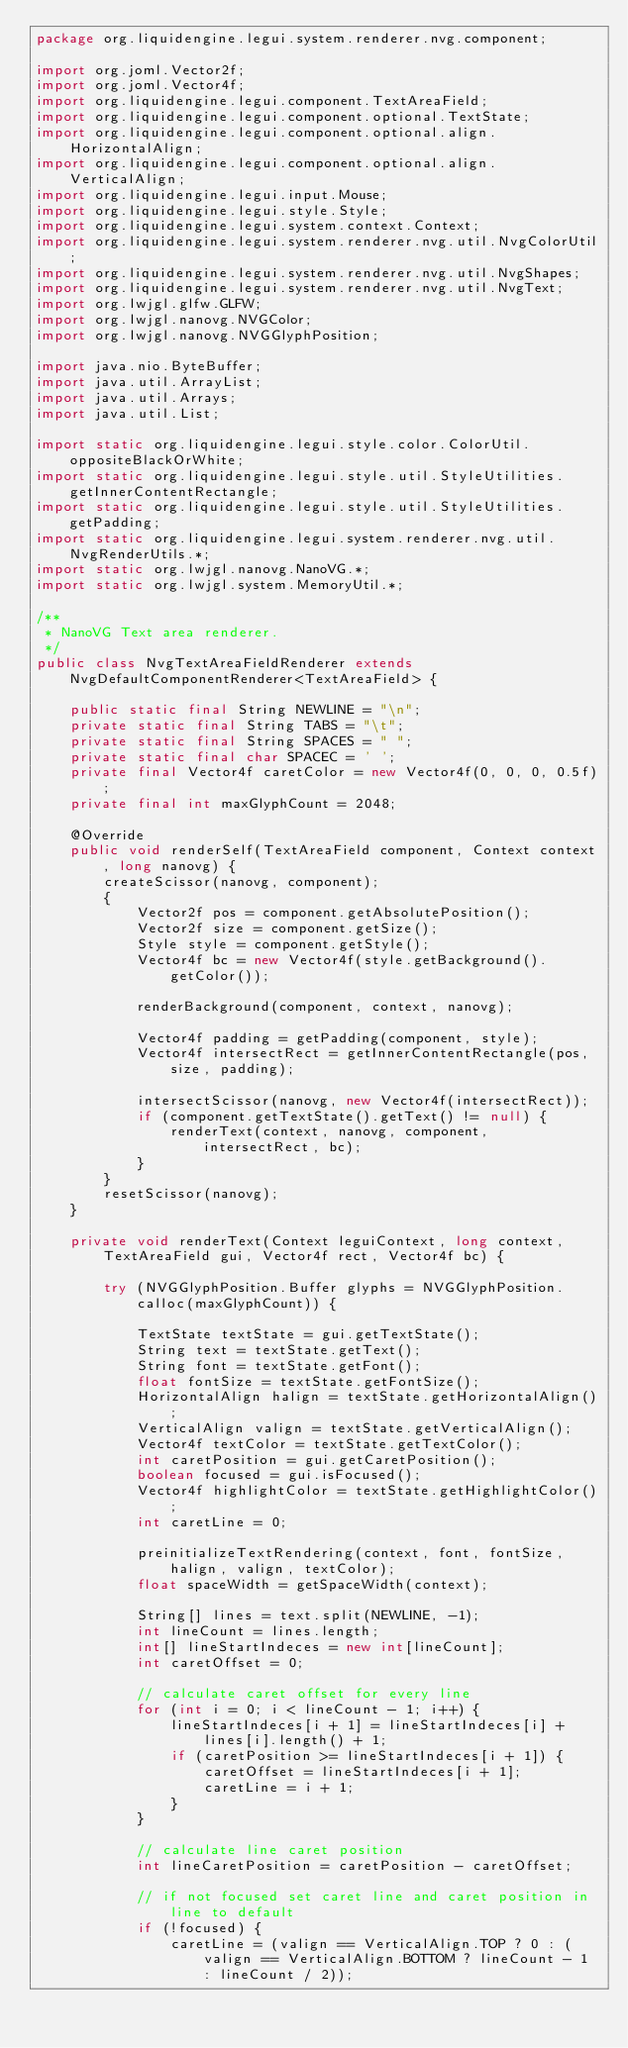Convert code to text. <code><loc_0><loc_0><loc_500><loc_500><_Java_>package org.liquidengine.legui.system.renderer.nvg.component;

import org.joml.Vector2f;
import org.joml.Vector4f;
import org.liquidengine.legui.component.TextAreaField;
import org.liquidengine.legui.component.optional.TextState;
import org.liquidengine.legui.component.optional.align.HorizontalAlign;
import org.liquidengine.legui.component.optional.align.VerticalAlign;
import org.liquidengine.legui.input.Mouse;
import org.liquidengine.legui.style.Style;
import org.liquidengine.legui.system.context.Context;
import org.liquidengine.legui.system.renderer.nvg.util.NvgColorUtil;
import org.liquidengine.legui.system.renderer.nvg.util.NvgShapes;
import org.liquidengine.legui.system.renderer.nvg.util.NvgText;
import org.lwjgl.glfw.GLFW;
import org.lwjgl.nanovg.NVGColor;
import org.lwjgl.nanovg.NVGGlyphPosition;

import java.nio.ByteBuffer;
import java.util.ArrayList;
import java.util.Arrays;
import java.util.List;

import static org.liquidengine.legui.style.color.ColorUtil.oppositeBlackOrWhite;
import static org.liquidengine.legui.style.util.StyleUtilities.getInnerContentRectangle;
import static org.liquidengine.legui.style.util.StyleUtilities.getPadding;
import static org.liquidengine.legui.system.renderer.nvg.util.NvgRenderUtils.*;
import static org.lwjgl.nanovg.NanoVG.*;
import static org.lwjgl.system.MemoryUtil.*;

/**
 * NanoVG Text area renderer.
 */
public class NvgTextAreaFieldRenderer extends NvgDefaultComponentRenderer<TextAreaField> {

    public static final String NEWLINE = "\n";
    private static final String TABS = "\t";
    private static final String SPACES = " ";
    private static final char SPACEC = ' ';
    private final Vector4f caretColor = new Vector4f(0, 0, 0, 0.5f);
    private final int maxGlyphCount = 2048;

    @Override
    public void renderSelf(TextAreaField component, Context context, long nanovg) {
        createScissor(nanovg, component);
        {
            Vector2f pos = component.getAbsolutePosition();
            Vector2f size = component.getSize();
            Style style = component.getStyle();
            Vector4f bc = new Vector4f(style.getBackground().getColor());

            renderBackground(component, context, nanovg);

            Vector4f padding = getPadding(component, style);
            Vector4f intersectRect = getInnerContentRectangle(pos, size, padding);

            intersectScissor(nanovg, new Vector4f(intersectRect));
            if (component.getTextState().getText() != null) {
                renderText(context, nanovg, component, intersectRect, bc);
            }
        }
        resetScissor(nanovg);
    }

    private void renderText(Context leguiContext, long context, TextAreaField gui, Vector4f rect, Vector4f bc) {

        try (NVGGlyphPosition.Buffer glyphs = NVGGlyphPosition.calloc(maxGlyphCount)) {

            TextState textState = gui.getTextState();
            String text = textState.getText();
            String font = textState.getFont();
            float fontSize = textState.getFontSize();
            HorizontalAlign halign = textState.getHorizontalAlign();
            VerticalAlign valign = textState.getVerticalAlign();
            Vector4f textColor = textState.getTextColor();
            int caretPosition = gui.getCaretPosition();
            boolean focused = gui.isFocused();
            Vector4f highlightColor = textState.getHighlightColor();
            int caretLine = 0;

            preinitializeTextRendering(context, font, fontSize, halign, valign, textColor);
            float spaceWidth = getSpaceWidth(context);

            String[] lines = text.split(NEWLINE, -1);
            int lineCount = lines.length;
            int[] lineStartIndeces = new int[lineCount];
            int caretOffset = 0;

            // calculate caret offset for every line
            for (int i = 0; i < lineCount - 1; i++) {
                lineStartIndeces[i + 1] = lineStartIndeces[i] + lines[i].length() + 1;
                if (caretPosition >= lineStartIndeces[i + 1]) {
                    caretOffset = lineStartIndeces[i + 1];
                    caretLine = i + 1;
                }
            }

            // calculate line caret position
            int lineCaretPosition = caretPosition - caretOffset;

            // if not focused set caret line and caret position in line to default
            if (!focused) {
                caretLine = (valign == VerticalAlign.TOP ? 0 : (valign == VerticalAlign.BOTTOM ? lineCount - 1 : lineCount / 2));</code> 